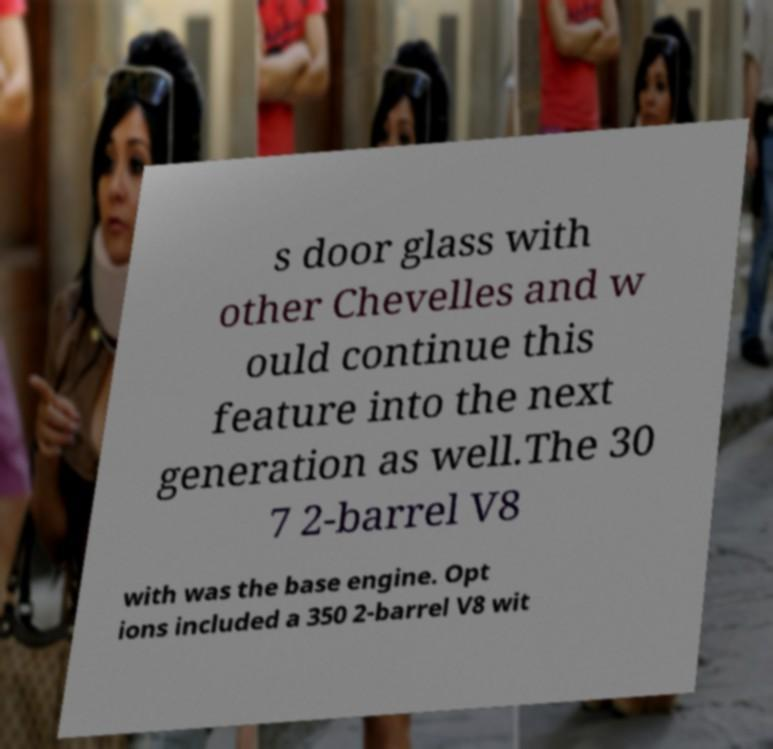Can you read and provide the text displayed in the image?This photo seems to have some interesting text. Can you extract and type it out for me? s door glass with other Chevelles and w ould continue this feature into the next generation as well.The 30 7 2-barrel V8 with was the base engine. Opt ions included a 350 2-barrel V8 wit 